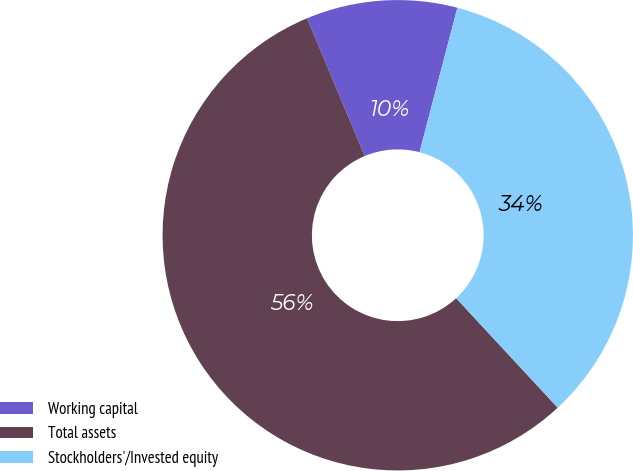<chart> <loc_0><loc_0><loc_500><loc_500><pie_chart><fcel>Working capital<fcel>Total assets<fcel>Stockholders'/Invested equity<nl><fcel>10.38%<fcel>55.6%<fcel>34.02%<nl></chart> 